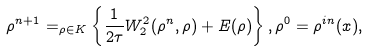<formula> <loc_0><loc_0><loc_500><loc_500>\rho ^ { n + 1 } = _ { \rho \in K } \left \{ \frac { 1 } { 2 \tau } W ^ { 2 } _ { 2 } ( \rho ^ { n } , \rho ) + E ( \rho ) \right \} , \rho ^ { 0 } = \rho ^ { i n } ( x ) ,</formula> 